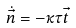<formula> <loc_0><loc_0><loc_500><loc_500>\dot { \vec { n } } = - { \kappa } { \tau } \vec { t }</formula> 